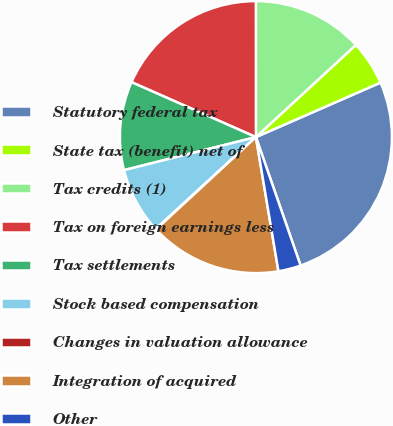<chart> <loc_0><loc_0><loc_500><loc_500><pie_chart><fcel>Statutory federal tax<fcel>State tax (benefit) net of<fcel>Tax credits (1)<fcel>Tax on foreign earnings less<fcel>Tax settlements<fcel>Stock based compensation<fcel>Changes in valuation allowance<fcel>Integration of acquired<fcel>Other<nl><fcel>26.24%<fcel>5.29%<fcel>13.15%<fcel>18.38%<fcel>10.53%<fcel>7.91%<fcel>0.06%<fcel>15.77%<fcel>2.68%<nl></chart> 